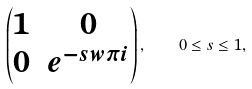<formula> <loc_0><loc_0><loc_500><loc_500>\left ( \begin{matrix} 1 & 0 \\ 0 & e ^ { - s w \pi i } \end{matrix} \right ) , \quad 0 \leq s \leq 1 ,</formula> 